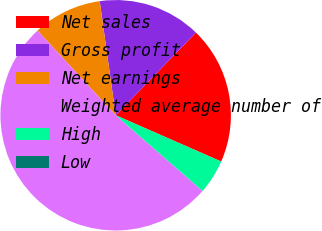Convert chart. <chart><loc_0><loc_0><loc_500><loc_500><pie_chart><fcel>Net sales<fcel>Gross profit<fcel>Net earnings<fcel>Weighted average number of<fcel>High<fcel>Low<nl><fcel>19.31%<fcel>14.48%<fcel>9.65%<fcel>51.73%<fcel>4.83%<fcel>0.0%<nl></chart> 